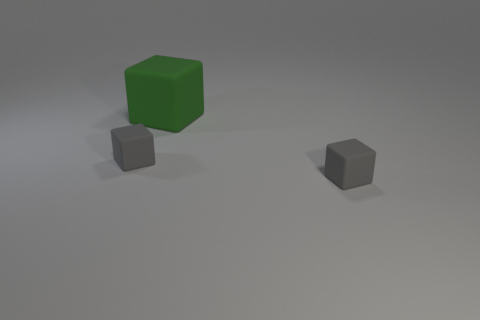There is a tiny gray cube that is left of the gray object right of the tiny rubber cube on the left side of the large matte thing; what is it made of?
Your answer should be very brief. Rubber. How many other big green objects have the same material as the green thing?
Your answer should be compact. 0. Do the matte object that is left of the large cube and the tiny object that is to the right of the big green rubber thing have the same shape?
Your answer should be compact. Yes. What color is the thing that is on the left side of the big green rubber thing?
Your response must be concise. Gray. Are there any tiny rubber things of the same shape as the big object?
Provide a succinct answer. Yes. What is the large object made of?
Offer a very short reply. Rubber. What number of tiny gray cubes are there?
Your answer should be compact. 2. Are there fewer big blocks than small cubes?
Ensure brevity in your answer.  Yes. How many things are either small objects or big red metallic blocks?
Give a very brief answer. 2. Are there fewer blocks that are to the left of the green rubber block than green matte blocks?
Provide a short and direct response. No. 